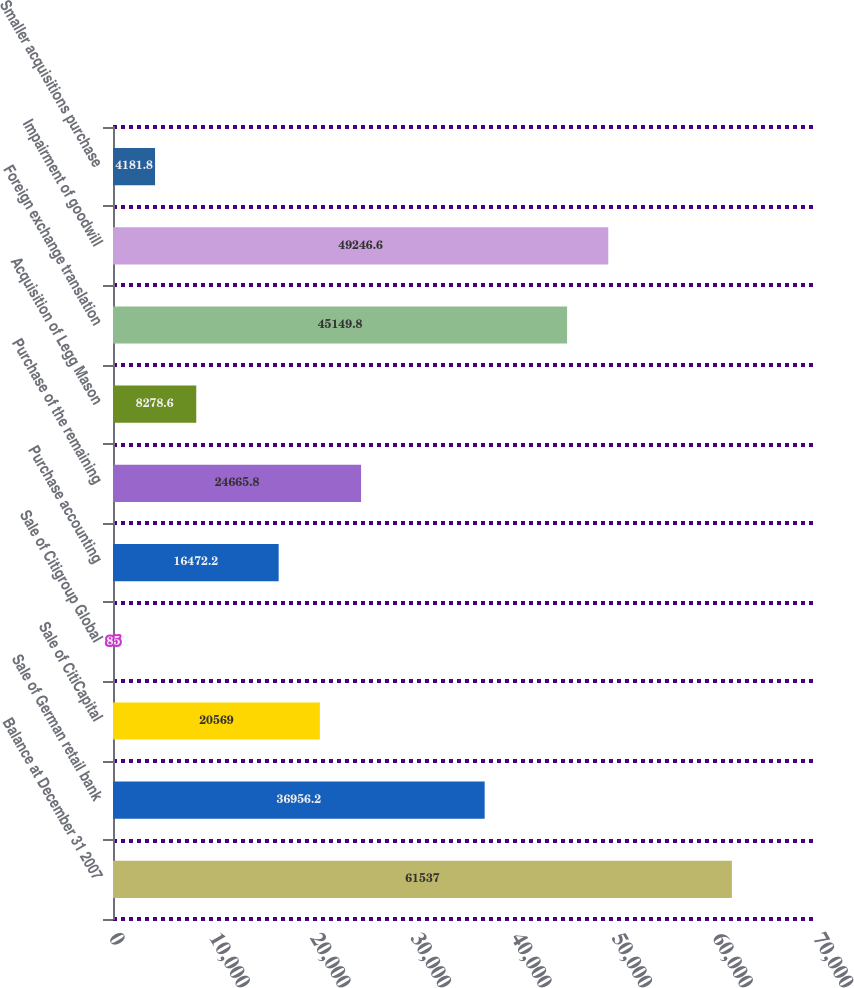<chart> <loc_0><loc_0><loc_500><loc_500><bar_chart><fcel>Balance at December 31 2007<fcel>Sale of German retail bank<fcel>Sale of CitiCapital<fcel>Sale of Citigroup Global<fcel>Purchase accounting<fcel>Purchase of the remaining<fcel>Acquisition of Legg Mason<fcel>Foreign exchange translation<fcel>Impairment of goodwill<fcel>Smaller acquisitions purchase<nl><fcel>61537<fcel>36956.2<fcel>20569<fcel>85<fcel>16472.2<fcel>24665.8<fcel>8278.6<fcel>45149.8<fcel>49246.6<fcel>4181.8<nl></chart> 